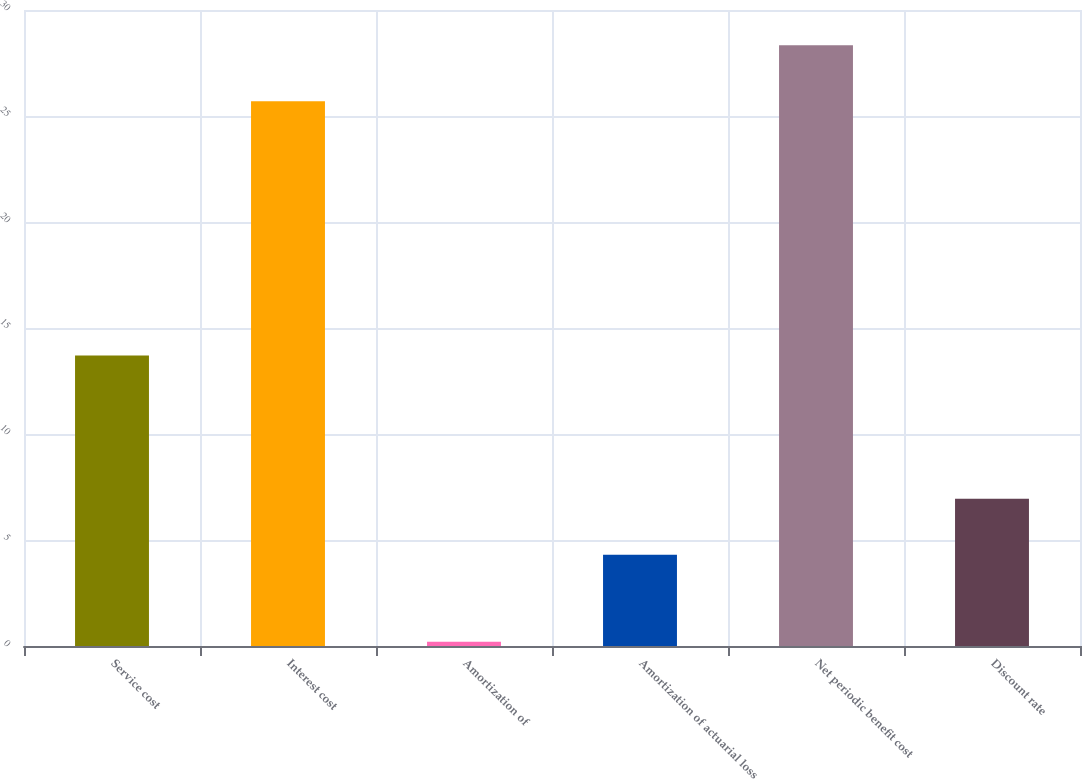Convert chart. <chart><loc_0><loc_0><loc_500><loc_500><bar_chart><fcel>Service cost<fcel>Interest cost<fcel>Amortization of<fcel>Amortization of actuarial loss<fcel>Net periodic benefit cost<fcel>Discount rate<nl><fcel>13.7<fcel>25.7<fcel>0.2<fcel>4.3<fcel>28.34<fcel>6.94<nl></chart> 